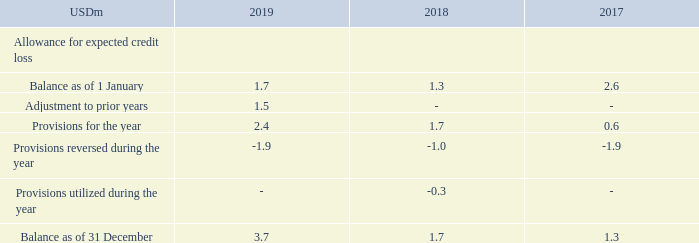Management makes allowance for expected credit loss based on the simplified approach to provide for expected credit losses, which permits the use of the lifetime expected loss provision for all trade receivables. Expected credit loss for receivables overdue more than 180 days is 25%-100%, depending on category. Expected credit loss for receivables overdue more than one year is 100%.
Movements in provisions for impairment of freight receivables during the year are as follows:
Allowance for expected credit loss of freight receivables have been recognized in the income statement under "Port expenses, bunkers and commissions".
Allowance for expected credit loss of freight receivables is calculated using an ageing factor as well as a specific customer knowledge and is based on a provision matrix on days past due.
What is recognized in the income statement under Port expenses, bunkers and commissions? Allowance for expected credit loss of freight receivables. How is allowance for expected credit loss of freight receivables calculated? Using an ageing factor as well as a specific customer knowledge and is based on a provision matrix on days past due. For which years are the movements in provisions for impairment of freight receivables during the year recorded? 2019, 2018, 2017. In which year was the Balance as of 1 January the largest? 2.6>1.7>1.3
Answer: 2017. What was the change in the Balance as of 31 December in 2019 from 2018?
Answer scale should be: million. 3.7-1.7
Answer: 2. What was the percentage change in the Balance as of 31 December in 2019 from 2018?
Answer scale should be: percent. (3.7-1.7)/1.7
Answer: 117.65. 